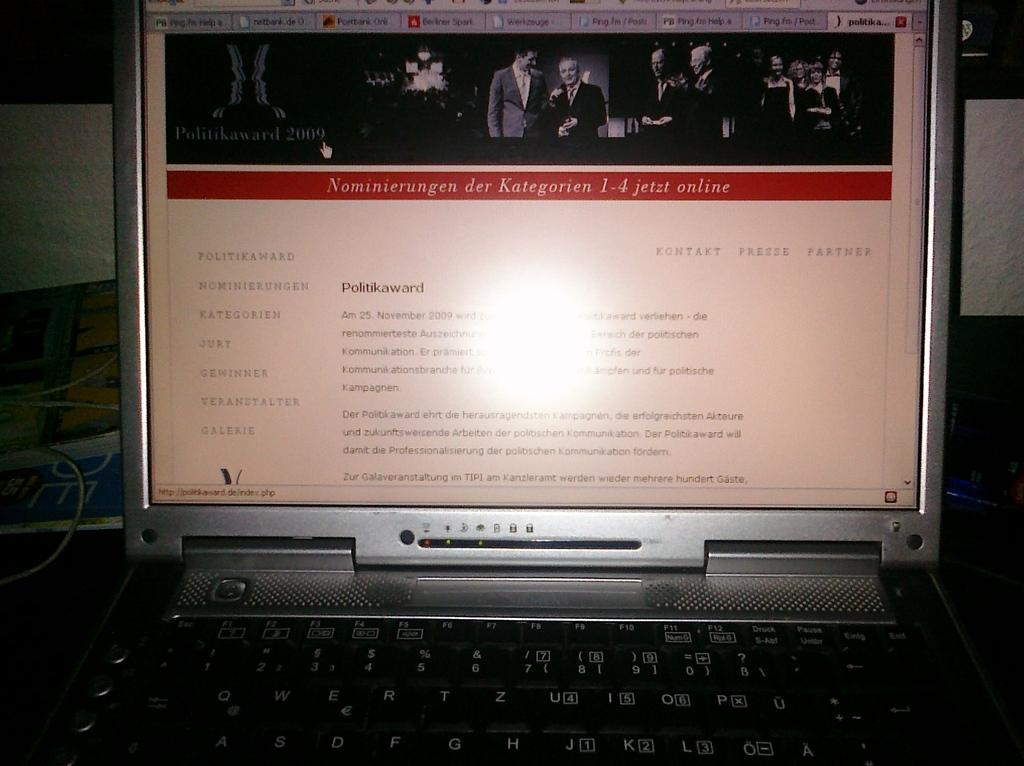<image>
Give a short and clear explanation of the subsequent image. a laptop with the screen on that says 'politikaward' on it 